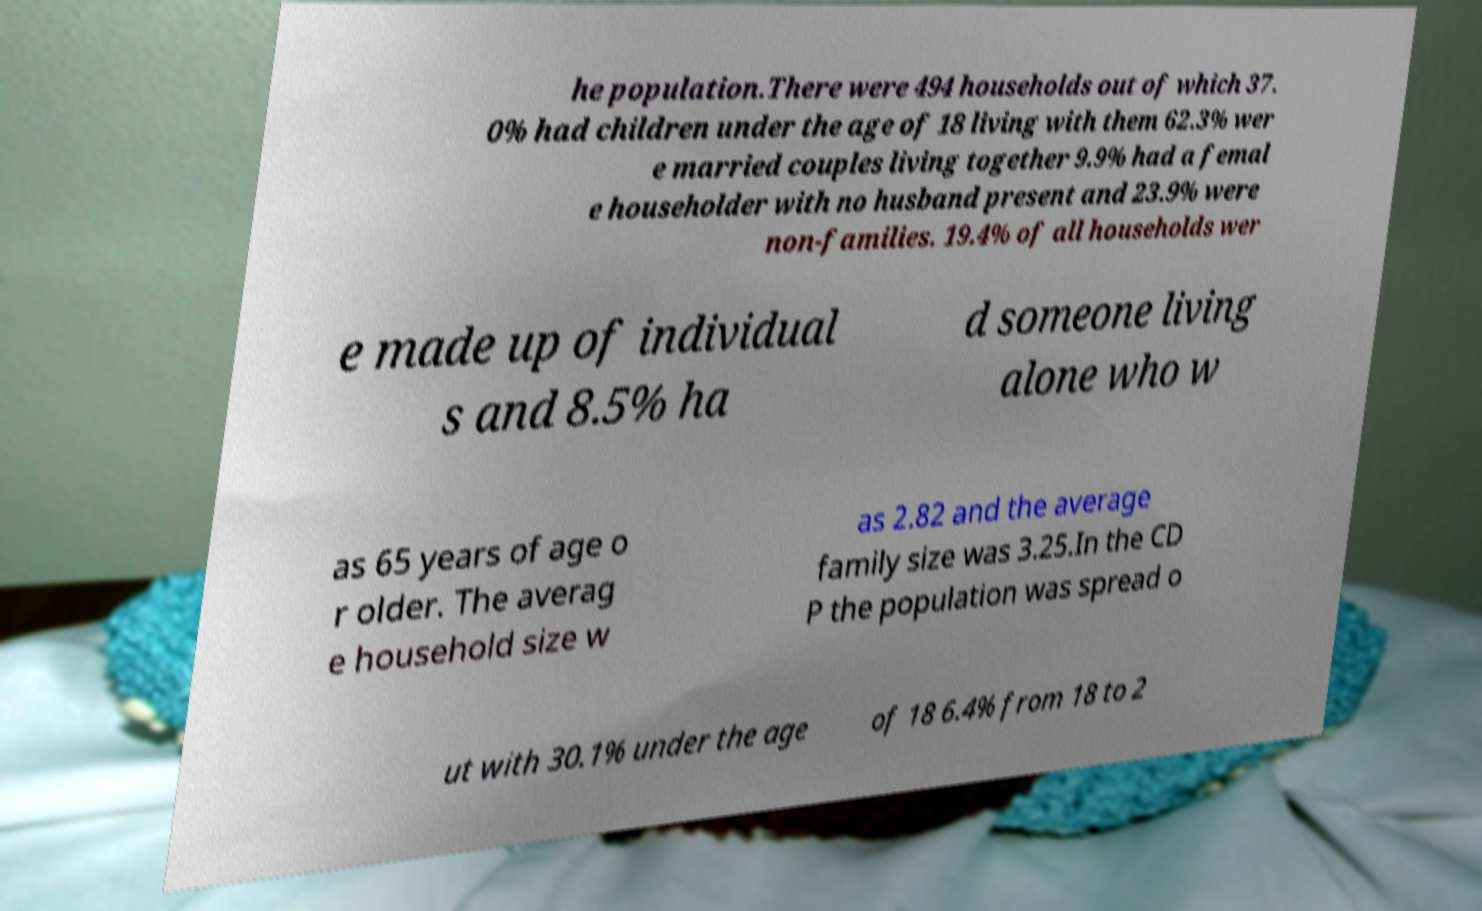For documentation purposes, I need the text within this image transcribed. Could you provide that? he population.There were 494 households out of which 37. 0% had children under the age of 18 living with them 62.3% wer e married couples living together 9.9% had a femal e householder with no husband present and 23.9% were non-families. 19.4% of all households wer e made up of individual s and 8.5% ha d someone living alone who w as 65 years of age o r older. The averag e household size w as 2.82 and the average family size was 3.25.In the CD P the population was spread o ut with 30.1% under the age of 18 6.4% from 18 to 2 